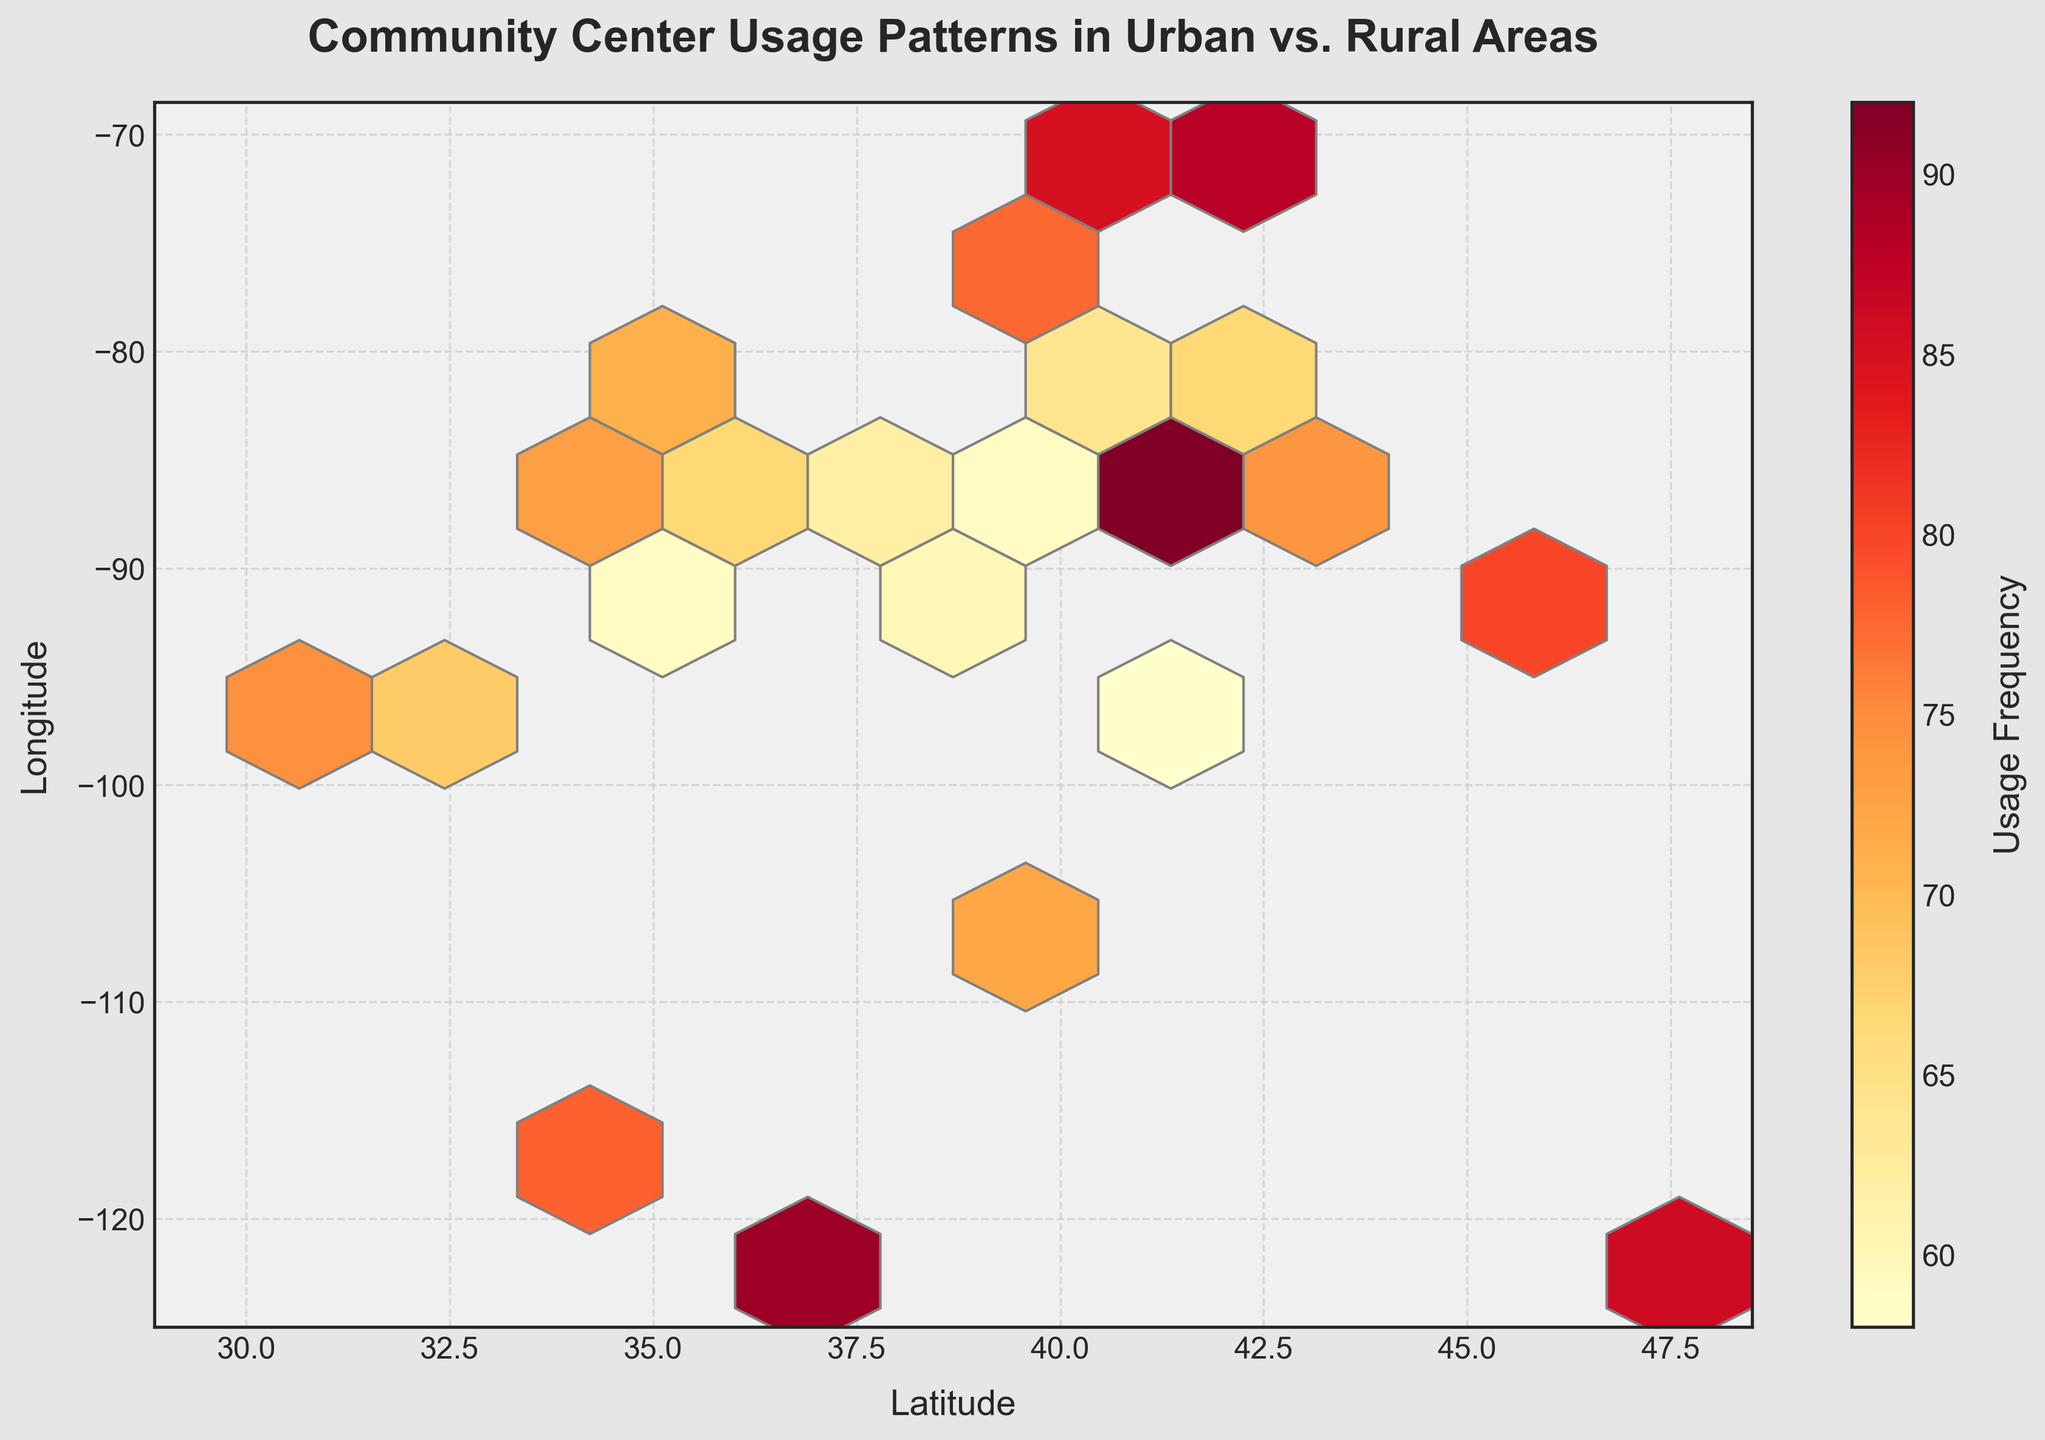What is the title of the plot? The title of the plot is usually found at the top of the figure and in this case, it is indicative of the data being presented.
Answer: Community Center Usage Patterns in Urban vs. Rural Areas What do the x and y axes represent? The axes labels usually describe what the x and y axes represent. In this case, the x-axis is labeled as 'Latitude' and the y-axis is labeled as 'Longitude'.
Answer: Latitude and Longitude What does the color scale represent? A colorbar usually indicates what the colors in the hexbin plot represent. Here, the colorbar is labeled 'Usage Frequency', which tells us that the color gradient represents the frequency of community center usage.
Answer: Usage Frequency Which latitude and longitude have the highest usage frequency? The darkest hexagons usually indicate the highest usage frequencies. By hovering over or examining the plot, you can find the coordinates of these hexagons.
Answer: It appears around Lat=41.8781, Long=-87.6298 How does the density of usage frequencies compare between urban and rural areas? Urban areas usually exhibit higher clustering and higher intensities in color shading compared to rural areas, which tend to have sparser and lighter-colored hexagons.
Answer: Higher in urban areas Where is the average usage frequency higher, Latitude > 39 or Latitude < 39? By visually inspecting the hexbin plot, you can determine which regions (latitude > 39 or < 39) exhibit more darker or intermediate shaded hexagons, indicative of higher average usage frequencies.
Answer: Latitude > 39 Which region shows a greater variation in usage, urban or rural? Variation in usage can be inferred from the spread and color intensity of hexagons in urban versus rural areas. Urban areas tend to have a wider range of colors from intermediate to dark shades, indicating greater variation in usage.
Answer: Urban areas In which part of the plot is the usage frequency least? The lightest hexagons represent the lowest usage frequencies. By scanning the plot, these hexagons can typically be found in the regions representing rural areas.
Answer: Rural areas What can you infer about community center usage near the coastal areas? Coastal areas are usually denoted by specific latitude and longitude ranges (e.g., coastal cities). Observing the color intensity in these areas can give an insight into the usage frequency.
Answer: Higher usage near coastal areas Is there a noticeable pattern in community center usage across different longitudes? By following the color gradient horizontally across the plot, one can observe if there are significant changes in usage frequency with changing longitude.
Answer: Yes, higher usage at longitudes corresponding to urban clusters 